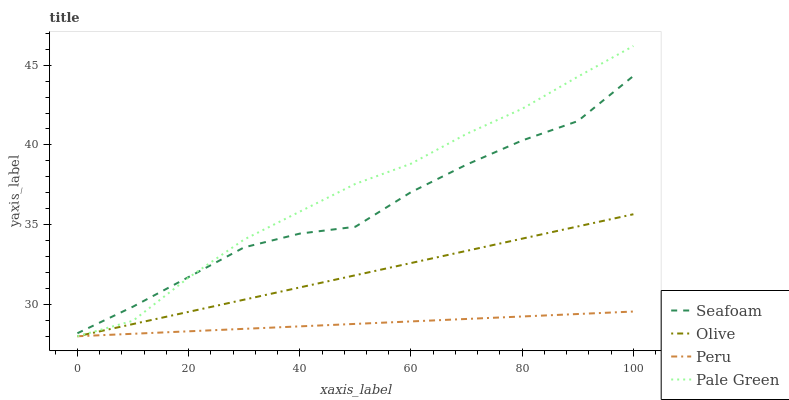Does Seafoam have the minimum area under the curve?
Answer yes or no. No. Does Seafoam have the maximum area under the curve?
Answer yes or no. No. Is Pale Green the smoothest?
Answer yes or no. No. Is Pale Green the roughest?
Answer yes or no. No. Does Seafoam have the lowest value?
Answer yes or no. No. Does Seafoam have the highest value?
Answer yes or no. No. Is Peru less than Seafoam?
Answer yes or no. Yes. Is Seafoam greater than Olive?
Answer yes or no. Yes. Does Peru intersect Seafoam?
Answer yes or no. No. 